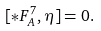Convert formula to latex. <formula><loc_0><loc_0><loc_500><loc_500>[ \ast { F ^ { 7 } _ { A } } , \eta ] = 0 .</formula> 